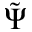<formula> <loc_0><loc_0><loc_500><loc_500>\tilde { \Psi }</formula> 